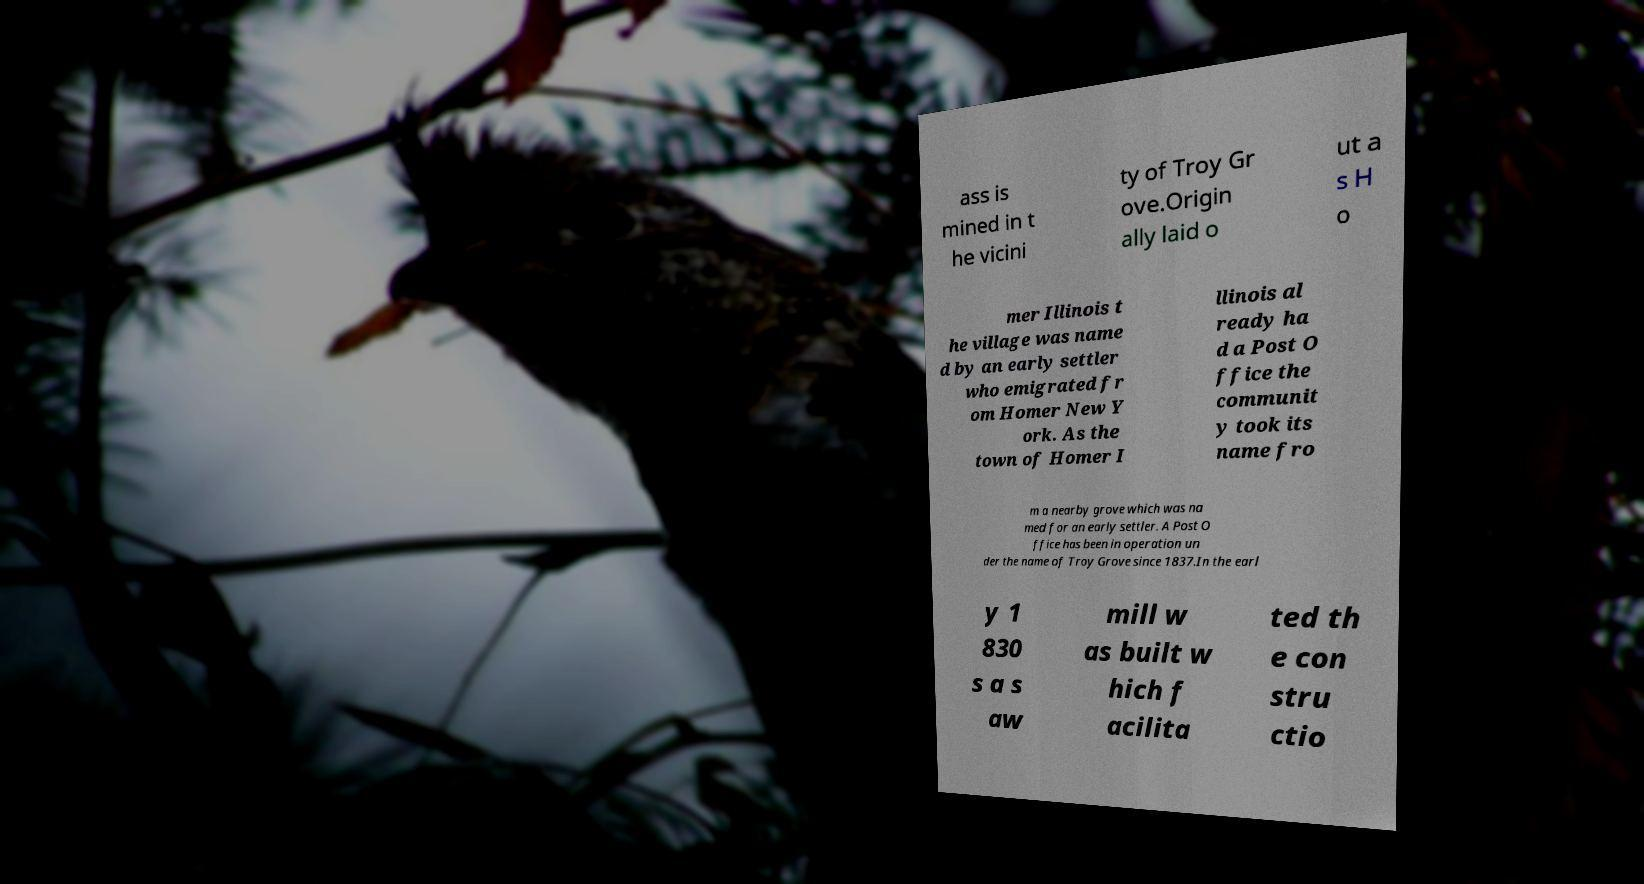What messages or text are displayed in this image? I need them in a readable, typed format. ass is mined in t he vicini ty of Troy Gr ove.Origin ally laid o ut a s H o mer Illinois t he village was name d by an early settler who emigrated fr om Homer New Y ork. As the town of Homer I llinois al ready ha d a Post O ffice the communit y took its name fro m a nearby grove which was na med for an early settler. A Post O ffice has been in operation un der the name of Troy Grove since 1837.In the earl y 1 830 s a s aw mill w as built w hich f acilita ted th e con stru ctio 